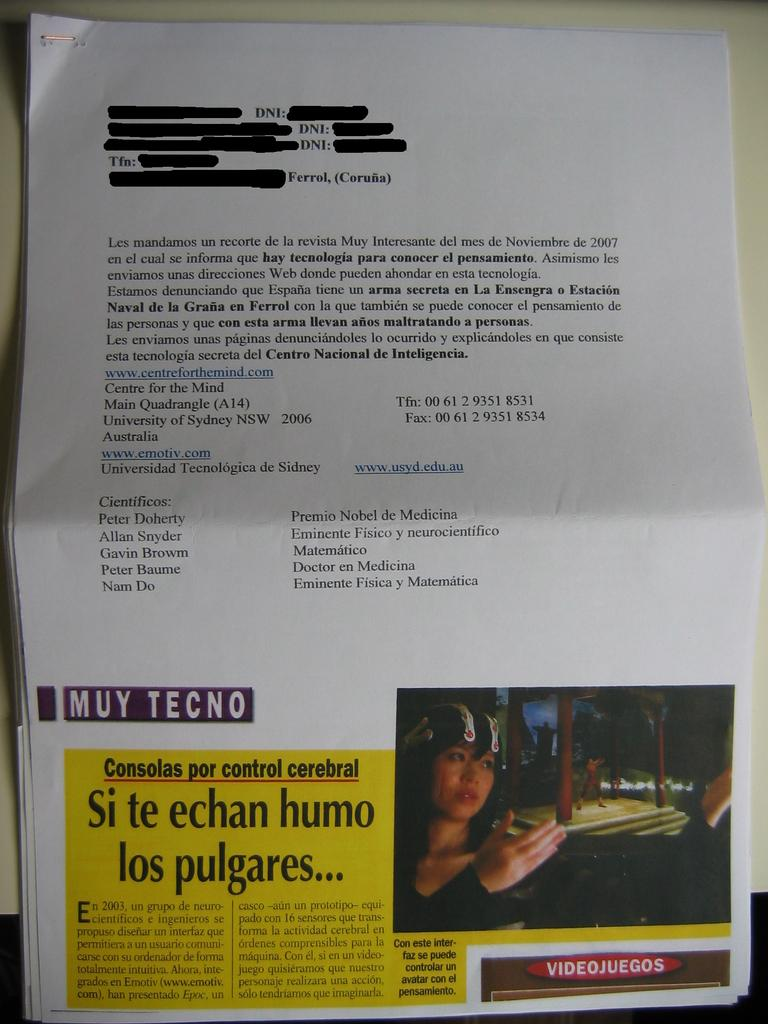What is on the paper that is visible in the image? There is text printed on the paper in the image. Where is the paper placed in the image? The paper is placed on a white table in the image. How many houses are visible in the image? There are no houses visible in the image; it only features a paper with text on a white table. 